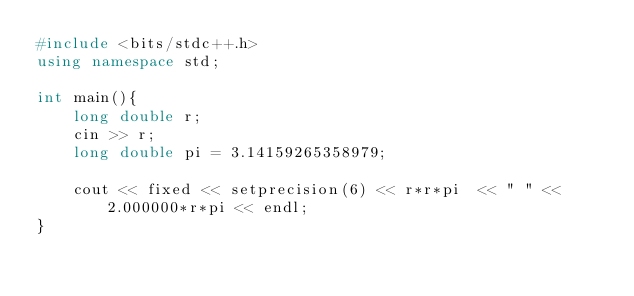Convert code to text. <code><loc_0><loc_0><loc_500><loc_500><_C++_>#include <bits/stdc++.h>
using namespace std;

int main(){
    long double r;
    cin >> r;
    long double pi = 3.14159265358979;

    cout << fixed << setprecision(6) << r*r*pi  << " " << 2.000000*r*pi << endl;
}
</code> 